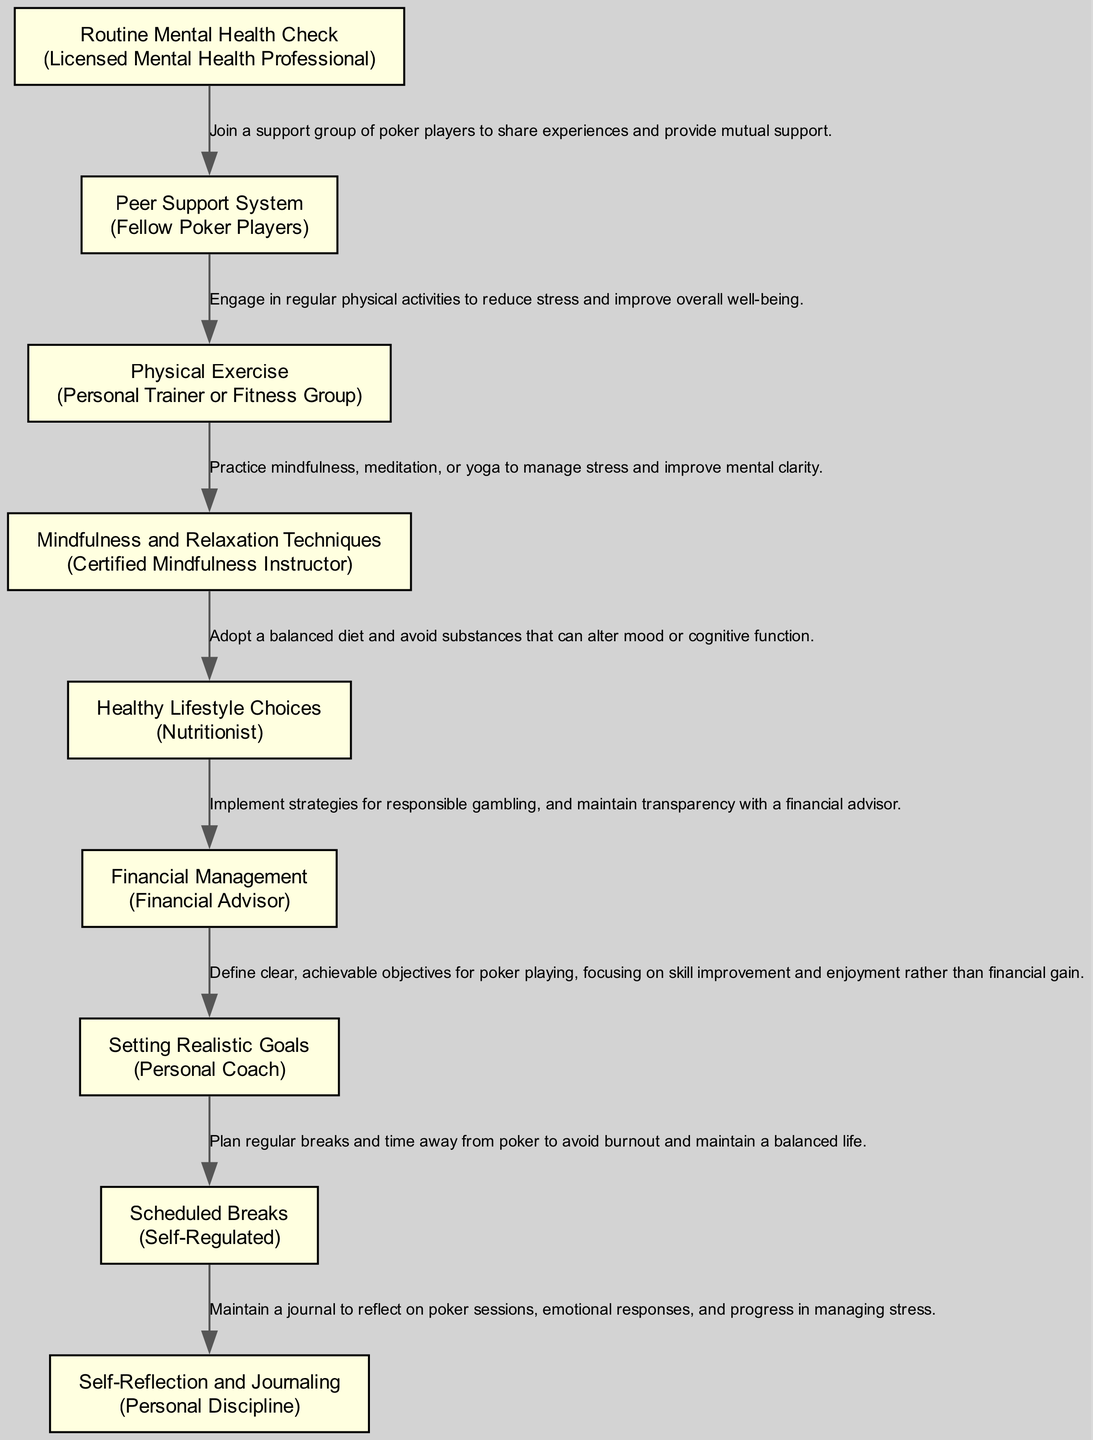What is the first element in the pathway? The first element in the pathway is labeled "Routine Mental Health Check." It is the initial step shown in the diagram.
Answer: Routine Mental Health Check How many nodes are in the diagram? The diagram contains a total of 9 nodes, each representing a different element related to managing poker-related stress.
Answer: 9 What entity is associated with "Mindfulness and Relaxation Techniques"? The entity linked to "Mindfulness and Relaxation Techniques" is "Certified Mindfulness Instructor," which indicates who provides this strategy in the pathway.
Answer: Certified Mindfulness Instructor Which element focuses on adopting a balanced diet? The element dedicated to adopting a balanced diet is "Healthy Lifestyle Choices," highlighting the importance of nutrition in managing stress.
Answer: Healthy Lifestyle Choices What element suggests taking planned breaks? The element that emphasizes the importance of planned breaks is "Scheduled Breaks," which aims to prevent burnout and maintain a balanced life.
Answer: Scheduled Breaks What two elements directly support mental health through interaction with others? "Peer Support System" and "Routine Mental Health Check" both involve interaction with others, focusing on sharing experiences and professional support to manage stress.
Answer: Peer Support System, Routine Mental Health Check Which element is related to managing finances responsibly? The element that addresses responsible financial management is "Financial Management," which involves working with a financial advisor for gambling transparency.
Answer: Financial Management What is the last element in the pathway? The last element in the pathway is "Self-Reflection and Journaling," encouraging self-discipline and awareness of emotional responses related to poker.
Answer: Self-Reflection and Journaling What role does "Personal Coach" play in the pathway? "Personal Coach" is responsible for helping to set realistic goals for poker playing, focusing on enjoyment and skill improvement rather than financial gain.
Answer: Personal Coach 